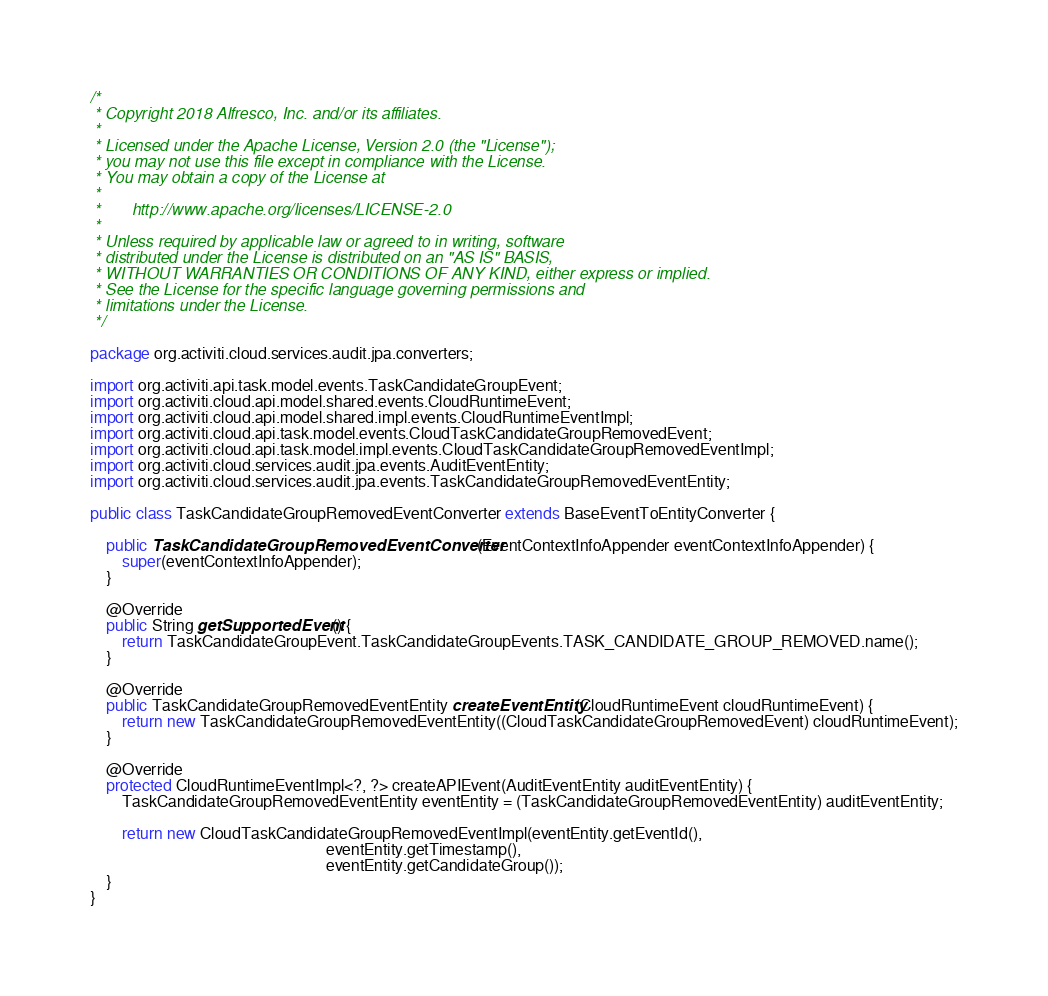<code> <loc_0><loc_0><loc_500><loc_500><_Java_>/*
 * Copyright 2018 Alfresco, Inc. and/or its affiliates.
 *
 * Licensed under the Apache License, Version 2.0 (the "License");
 * you may not use this file except in compliance with the License.
 * You may obtain a copy of the License at
 *
 *       http://www.apache.org/licenses/LICENSE-2.0
 *
 * Unless required by applicable law or agreed to in writing, software
 * distributed under the License is distributed on an "AS IS" BASIS,
 * WITHOUT WARRANTIES OR CONDITIONS OF ANY KIND, either express or implied.
 * See the License for the specific language governing permissions and
 * limitations under the License.
 */

package org.activiti.cloud.services.audit.jpa.converters;

import org.activiti.api.task.model.events.TaskCandidateGroupEvent;
import org.activiti.cloud.api.model.shared.events.CloudRuntimeEvent;
import org.activiti.cloud.api.model.shared.impl.events.CloudRuntimeEventImpl;
import org.activiti.cloud.api.task.model.events.CloudTaskCandidateGroupRemovedEvent;
import org.activiti.cloud.api.task.model.impl.events.CloudTaskCandidateGroupRemovedEventImpl;
import org.activiti.cloud.services.audit.jpa.events.AuditEventEntity;
import org.activiti.cloud.services.audit.jpa.events.TaskCandidateGroupRemovedEventEntity;

public class TaskCandidateGroupRemovedEventConverter extends BaseEventToEntityConverter {

    public TaskCandidateGroupRemovedEventConverter(EventContextInfoAppender eventContextInfoAppender) {
        super(eventContextInfoAppender);
    }
    
    @Override
    public String getSupportedEvent() {
        return TaskCandidateGroupEvent.TaskCandidateGroupEvents.TASK_CANDIDATE_GROUP_REMOVED.name();
    }

    @Override
    public TaskCandidateGroupRemovedEventEntity createEventEntity(CloudRuntimeEvent cloudRuntimeEvent) {             
        return new TaskCandidateGroupRemovedEventEntity((CloudTaskCandidateGroupRemovedEvent) cloudRuntimeEvent);
    }

    @Override
    protected CloudRuntimeEventImpl<?, ?> createAPIEvent(AuditEventEntity auditEventEntity) {
        TaskCandidateGroupRemovedEventEntity eventEntity = (TaskCandidateGroupRemovedEventEntity) auditEventEntity;

        return new CloudTaskCandidateGroupRemovedEventImpl(eventEntity.getEventId(),
                                                           eventEntity.getTimestamp(),
                                                           eventEntity.getCandidateGroup());
    }
}
</code> 